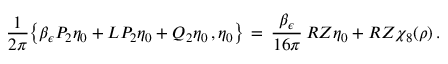<formula> <loc_0><loc_0><loc_500><loc_500>\frac { 1 } { 2 \pi } \left \{ \beta _ { \epsilon } P _ { 2 } \eta _ { 0 } + L P _ { 2 } \eta _ { 0 } + Q _ { 2 } \eta _ { 0 } \, , \eta _ { 0 } \right \} \, = \, \frac { \beta _ { \epsilon } } { 1 6 \pi } \, R Z \eta _ { 0 } + R Z \chi _ { 8 } ( \rho ) \, .</formula> 